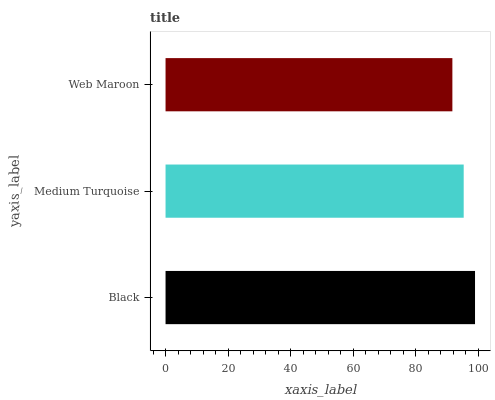Is Web Maroon the minimum?
Answer yes or no. Yes. Is Black the maximum?
Answer yes or no. Yes. Is Medium Turquoise the minimum?
Answer yes or no. No. Is Medium Turquoise the maximum?
Answer yes or no. No. Is Black greater than Medium Turquoise?
Answer yes or no. Yes. Is Medium Turquoise less than Black?
Answer yes or no. Yes. Is Medium Turquoise greater than Black?
Answer yes or no. No. Is Black less than Medium Turquoise?
Answer yes or no. No. Is Medium Turquoise the high median?
Answer yes or no. Yes. Is Medium Turquoise the low median?
Answer yes or no. Yes. Is Black the high median?
Answer yes or no. No. Is Web Maroon the low median?
Answer yes or no. No. 